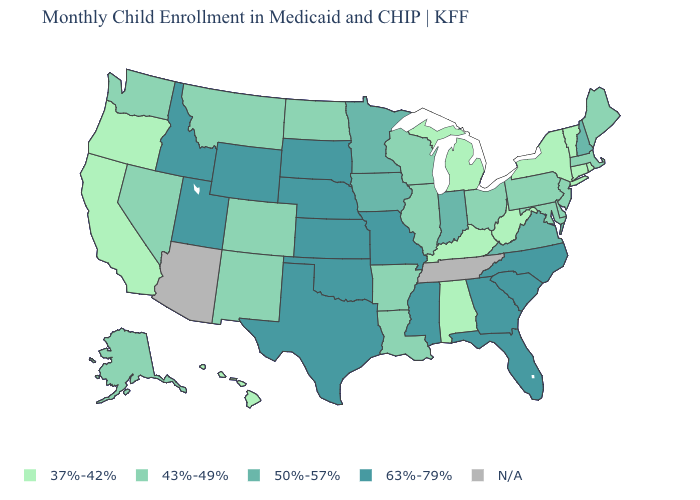Does the map have missing data?
Answer briefly. Yes. Which states have the lowest value in the USA?
Concise answer only. Alabama, California, Connecticut, Hawaii, Kentucky, Michigan, New York, Oregon, Rhode Island, Vermont, West Virginia. Does Alaska have the lowest value in the USA?
Be succinct. No. What is the value of Missouri?
Quick response, please. 63%-79%. Name the states that have a value in the range 43%-49%?
Be succinct. Alaska, Arkansas, Colorado, Delaware, Illinois, Louisiana, Maine, Maryland, Massachusetts, Montana, Nevada, New Jersey, New Mexico, North Dakota, Ohio, Pennsylvania, Washington, Wisconsin. Name the states that have a value in the range 43%-49%?
Concise answer only. Alaska, Arkansas, Colorado, Delaware, Illinois, Louisiana, Maine, Maryland, Massachusetts, Montana, Nevada, New Jersey, New Mexico, North Dakota, Ohio, Pennsylvania, Washington, Wisconsin. What is the highest value in the West ?
Write a very short answer. 63%-79%. Name the states that have a value in the range N/A?
Be succinct. Arizona, Tennessee. Name the states that have a value in the range 63%-79%?
Quick response, please. Florida, Georgia, Idaho, Kansas, Mississippi, Missouri, Nebraska, North Carolina, Oklahoma, South Carolina, South Dakota, Texas, Utah, Wyoming. What is the value of Pennsylvania?
Short answer required. 43%-49%. Does Michigan have the highest value in the USA?
Quick response, please. No. What is the value of California?
Answer briefly. 37%-42%. Name the states that have a value in the range N/A?
Concise answer only. Arizona, Tennessee. 